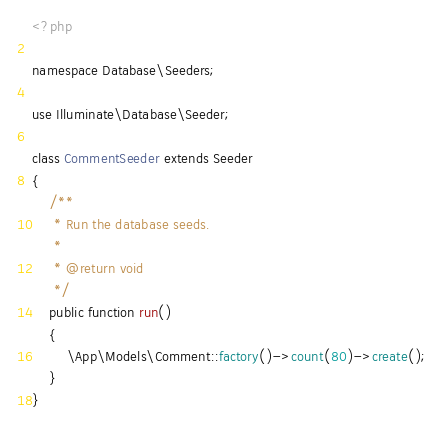<code> <loc_0><loc_0><loc_500><loc_500><_PHP_><?php

namespace Database\Seeders;

use Illuminate\Database\Seeder;

class CommentSeeder extends Seeder
{
    /**
     * Run the database seeds.
     *
     * @return void
     */
    public function run()
    {
        \App\Models\Comment::factory()->count(80)->create();
    }
}
</code> 